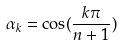Convert formula to latex. <formula><loc_0><loc_0><loc_500><loc_500>\alpha _ { k } = \cos ( \frac { k \pi } { n + 1 } )</formula> 